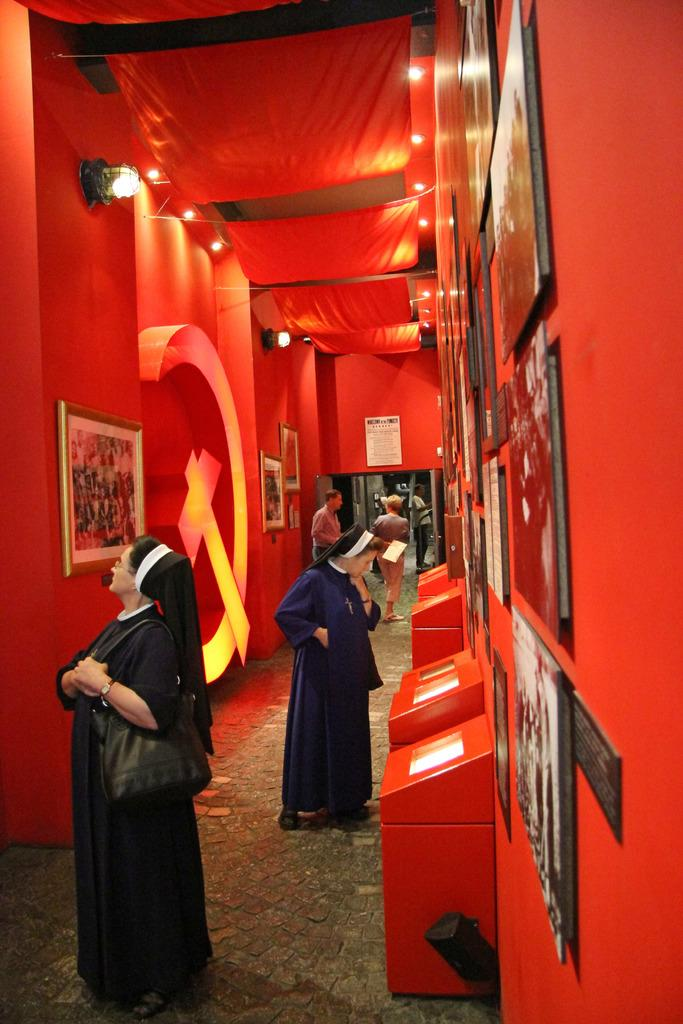Who or what can be seen in the image? There are people in the image. What is the background of the image? There is a wall in the image. Are there any decorative items in the image? Yes, photo frames and a poster are present in the image. What can be seen illuminating the scene? Lights are visible in the image. What else is present in the image? Clothes are present in the image. What is placed on the walkway at the bottom of the image? Red boxes are placed on the walkway at the bottom of the image. What type of hair can be seen on the tomatoes in the image? There are no tomatoes present in the image, and therefore no hair can be observed on them. 